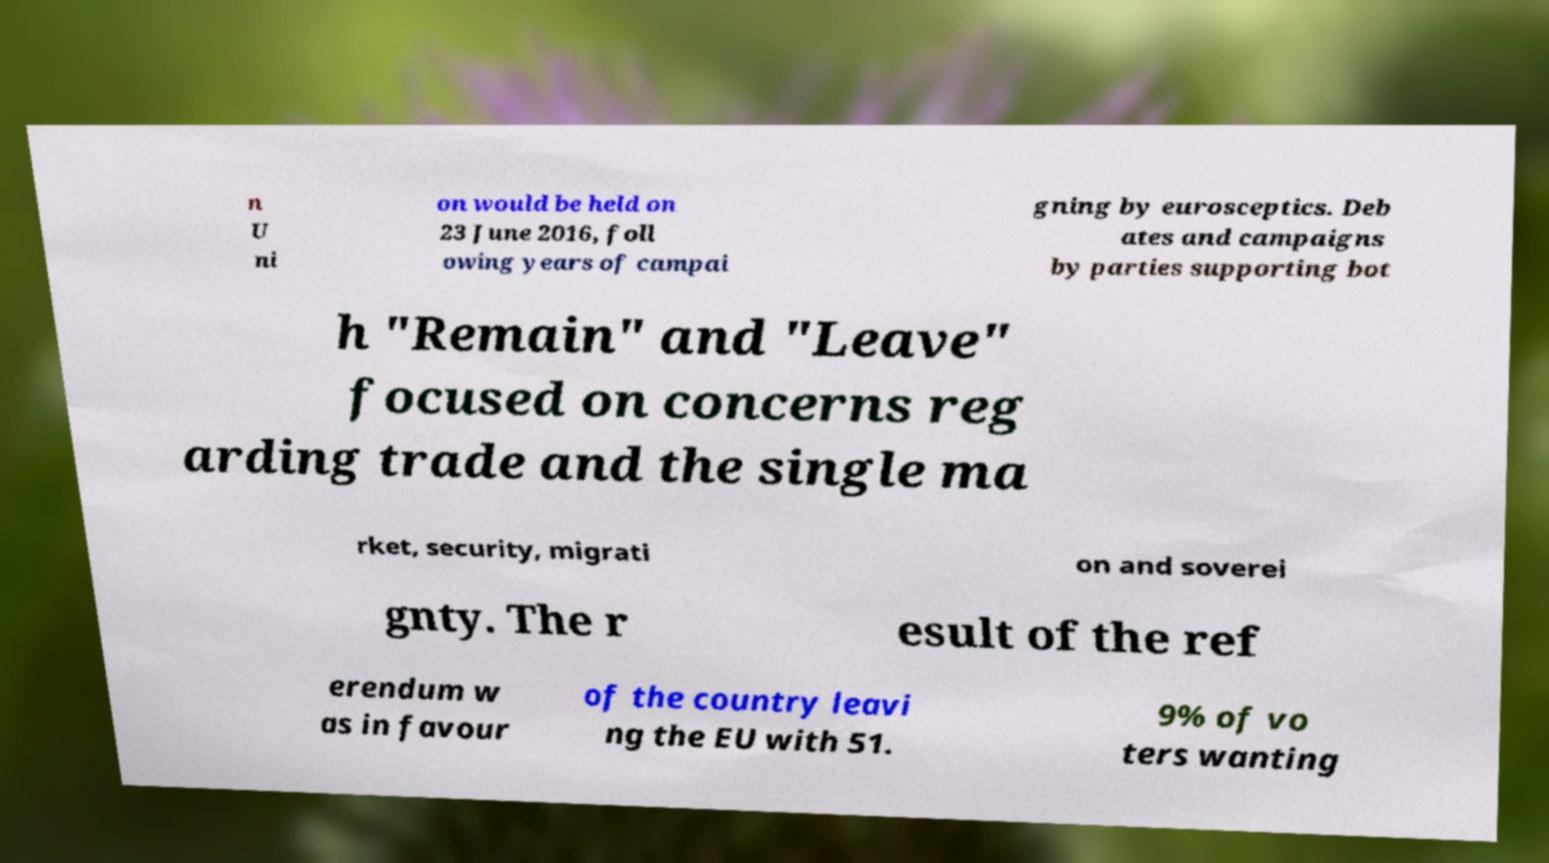There's text embedded in this image that I need extracted. Can you transcribe it verbatim? n U ni on would be held on 23 June 2016, foll owing years of campai gning by eurosceptics. Deb ates and campaigns by parties supporting bot h "Remain" and "Leave" focused on concerns reg arding trade and the single ma rket, security, migrati on and soverei gnty. The r esult of the ref erendum w as in favour of the country leavi ng the EU with 51. 9% of vo ters wanting 